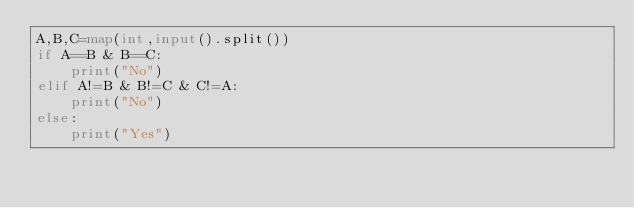Convert code to text. <code><loc_0><loc_0><loc_500><loc_500><_Python_>A,B,C=map(int,input().split())
if A==B & B==C:
    print("No")
elif A!=B & B!=C & C!=A:
    print("No")
else:
    print("Yes")
</code> 